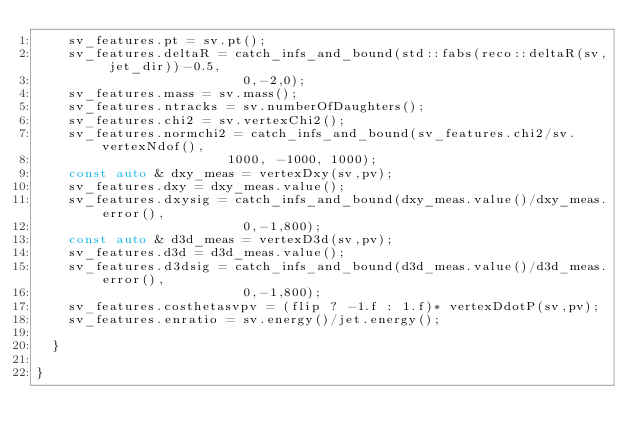Convert code to text. <code><loc_0><loc_0><loc_500><loc_500><_C++_>    sv_features.pt = sv.pt();
    sv_features.deltaR = catch_infs_and_bound(std::fabs(reco::deltaR(sv, jet_dir))-0.5,
					      0,-2,0);
    sv_features.mass = sv.mass();
    sv_features.ntracks = sv.numberOfDaughters();
    sv_features.chi2 = sv.vertexChi2();
    sv_features.normchi2 = catch_infs_and_bound(sv_features.chi2/sv.vertexNdof(),
						1000, -1000, 1000);
    const auto & dxy_meas = vertexDxy(sv,pv);
    sv_features.dxy = dxy_meas.value();
    sv_features.dxysig = catch_infs_and_bound(dxy_meas.value()/dxy_meas.error(),
					      0,-1,800);
    const auto & d3d_meas = vertexD3d(sv,pv);
    sv_features.d3d = d3d_meas.value();
    sv_features.d3dsig = catch_infs_and_bound(d3d_meas.value()/d3d_meas.error(),
					      0,-1,800);
    sv_features.costhetasvpv = (flip ? -1.f : 1.f)* vertexDdotP(sv,pv);
    sv_features.enratio = sv.energy()/jet.energy();

  }

}

</code> 